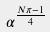Convert formula to latex. <formula><loc_0><loc_0><loc_500><loc_500>\alpha ^ { \frac { N \pi - 1 } { 4 } }</formula> 